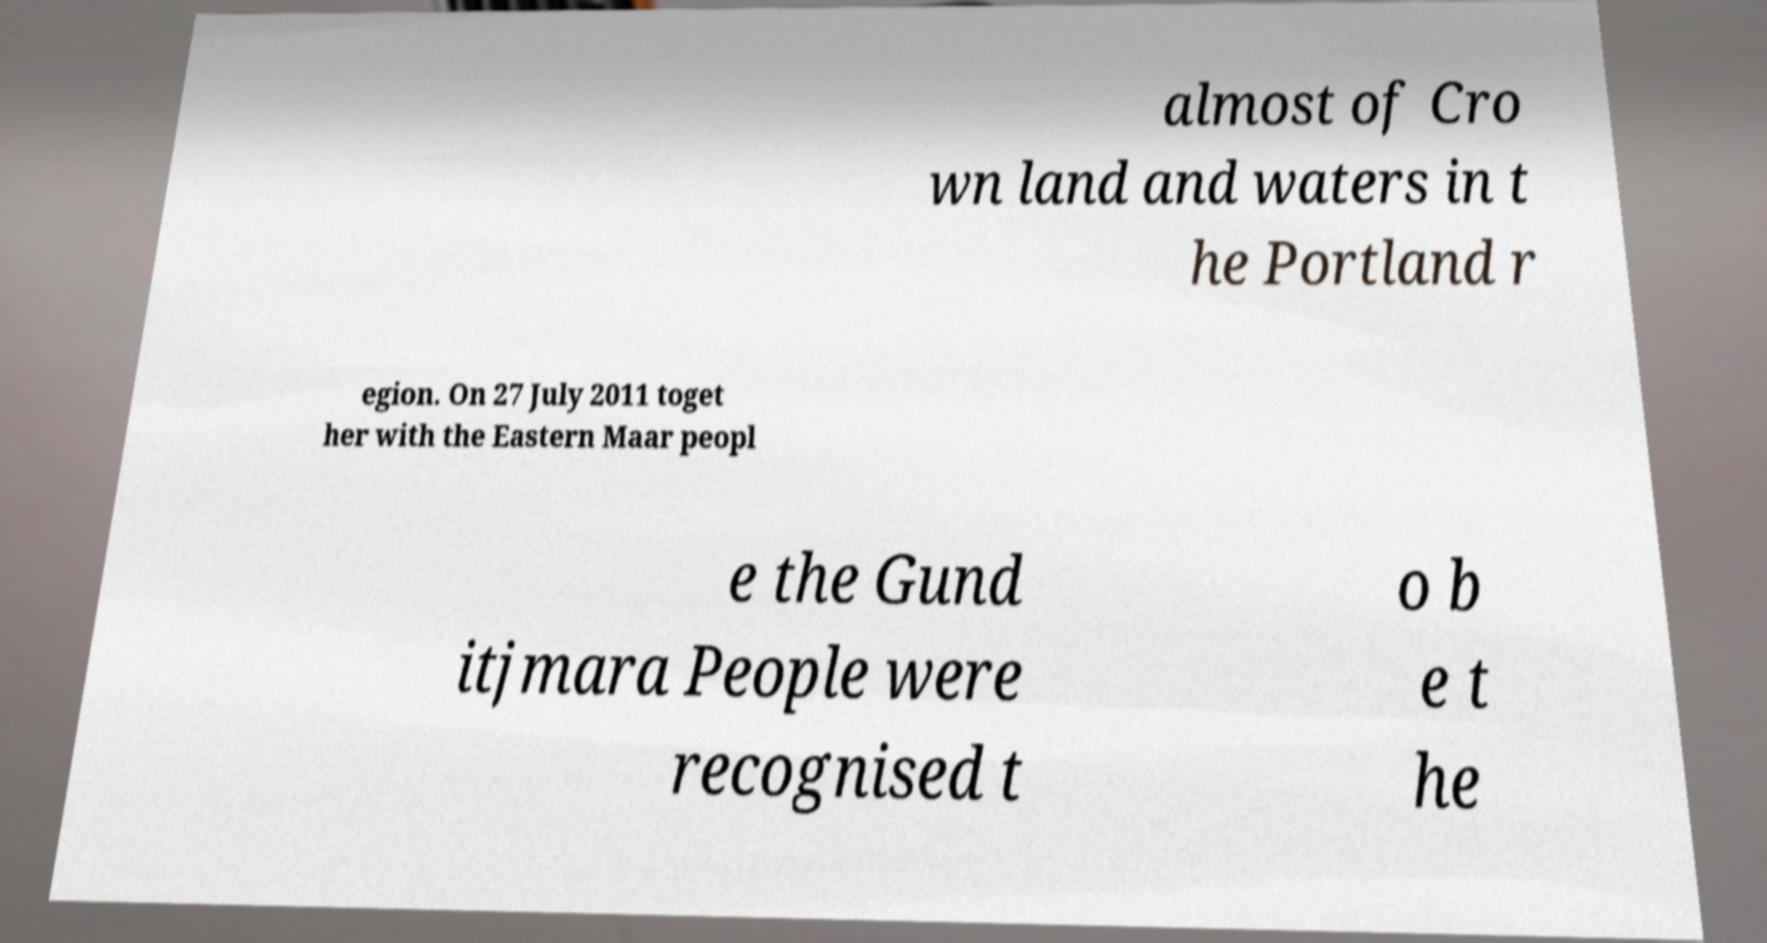There's text embedded in this image that I need extracted. Can you transcribe it verbatim? almost of Cro wn land and waters in t he Portland r egion. On 27 July 2011 toget her with the Eastern Maar peopl e the Gund itjmara People were recognised t o b e t he 